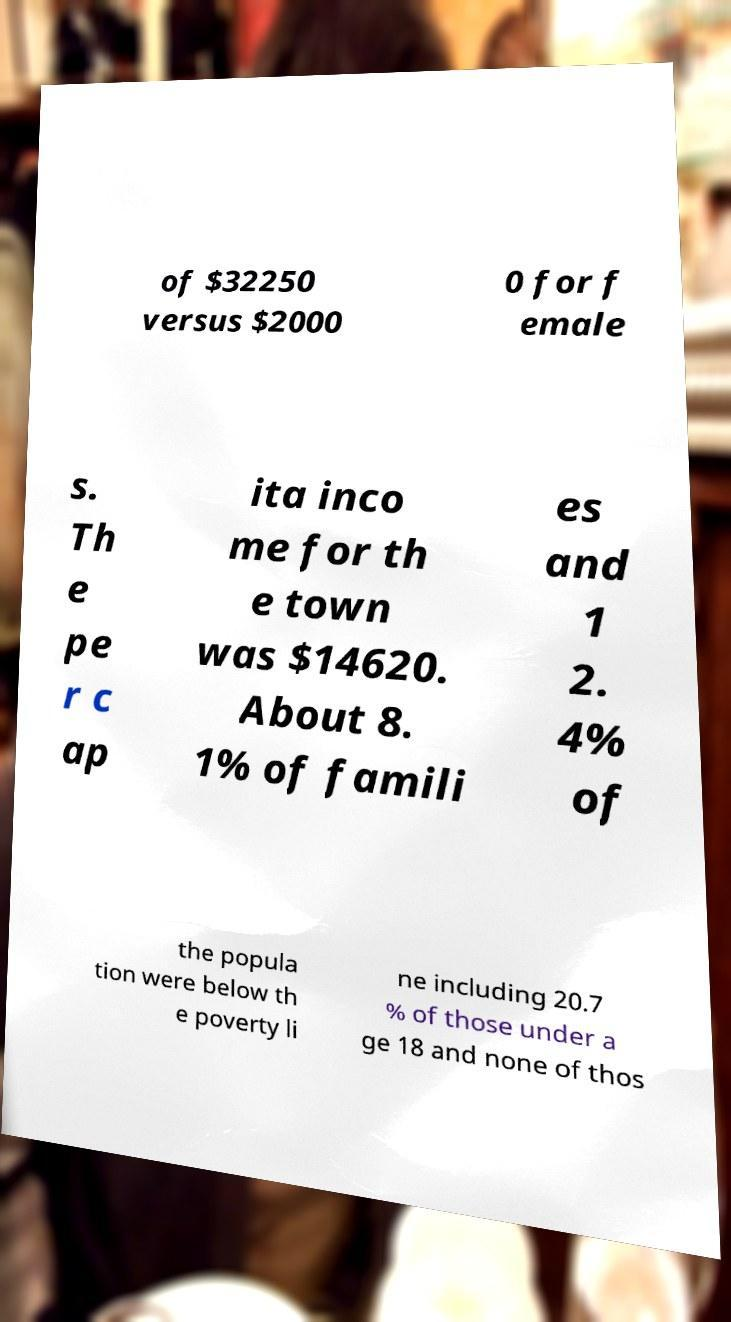Can you read and provide the text displayed in the image?This photo seems to have some interesting text. Can you extract and type it out for me? of $32250 versus $2000 0 for f emale s. Th e pe r c ap ita inco me for th e town was $14620. About 8. 1% of famili es and 1 2. 4% of the popula tion were below th e poverty li ne including 20.7 % of those under a ge 18 and none of thos 